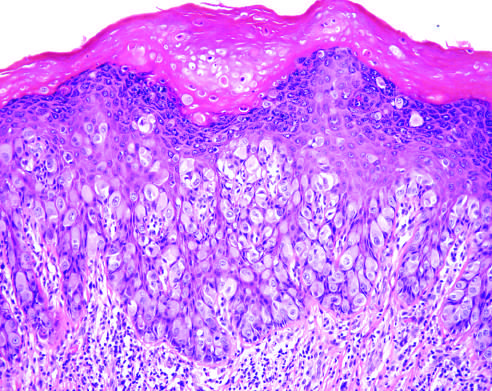re chronic inflammatory cells present in the underlying dermis?
Answer the question using a single word or phrase. Yes 